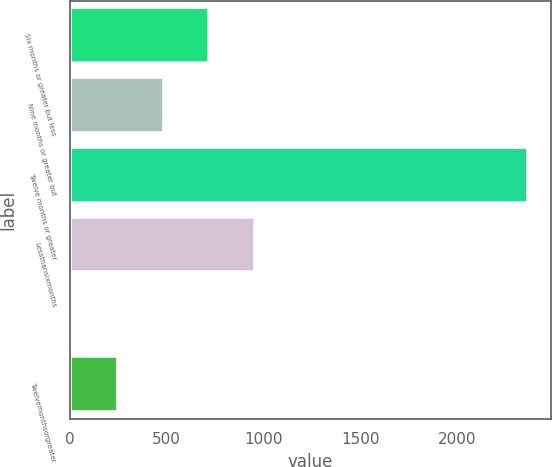Convert chart to OTSL. <chart><loc_0><loc_0><loc_500><loc_500><bar_chart><fcel>Six months or greater but less<fcel>Nine months or greater but<fcel>Twelve months or greater<fcel>Lessthansixmonths<fcel>Unnamed: 4<fcel>Twelvemonthsorgreater<nl><fcel>721.2<fcel>485.8<fcel>2369<fcel>956.6<fcel>15<fcel>250.4<nl></chart> 